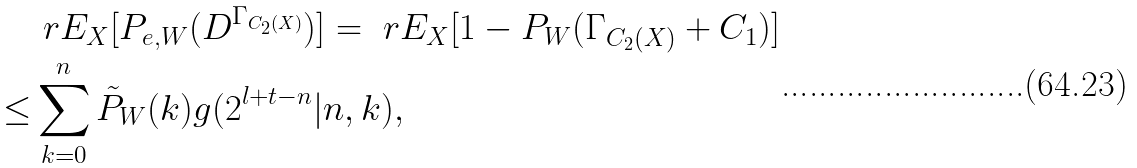<formula> <loc_0><loc_0><loc_500><loc_500>& \ r E _ { X } [ P _ { e , W } ( D ^ { \Gamma _ { C _ { 2 } ( X ) } } ) ] = \ r E _ { X } [ 1 - P _ { W } ( \Gamma _ { C _ { 2 } ( X ) } + C _ { 1 } ) ] \\ \leq & \sum _ { k = 0 } ^ { n } \tilde { P } _ { W } ( k ) g ( 2 ^ { l + t - n } | n , k ) ,</formula> 